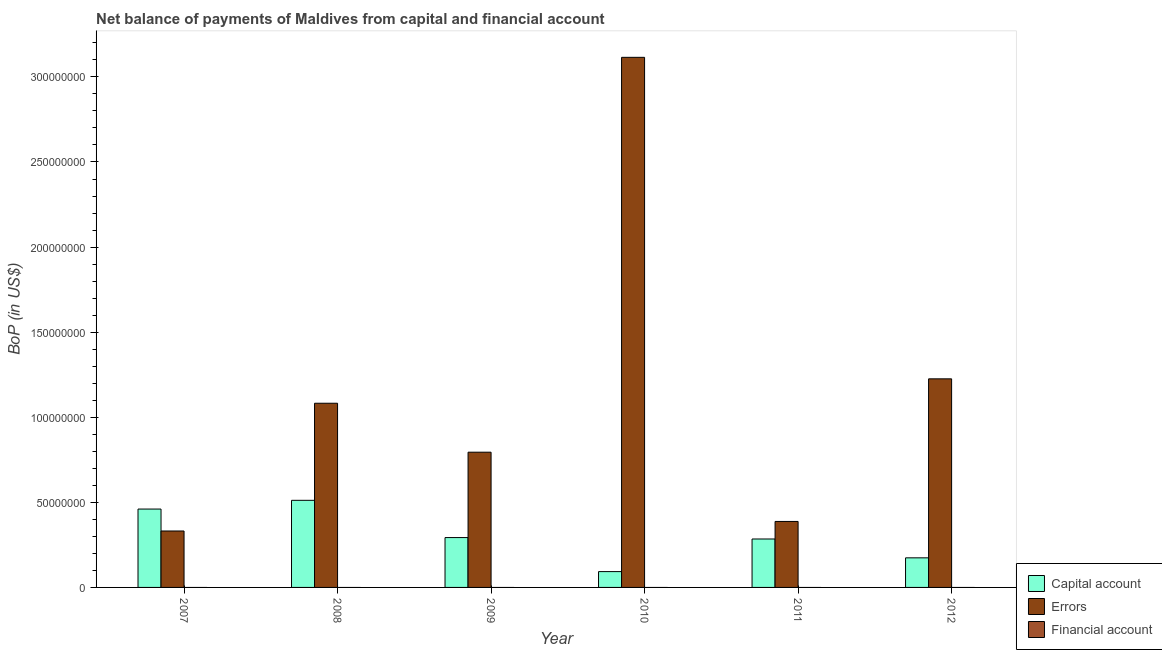How many different coloured bars are there?
Provide a short and direct response. 2. Are the number of bars on each tick of the X-axis equal?
Your answer should be very brief. Yes. What is the amount of errors in 2007?
Provide a short and direct response. 3.32e+07. Across all years, what is the maximum amount of net capital account?
Your response must be concise. 5.12e+07. Across all years, what is the minimum amount of errors?
Provide a succinct answer. 3.32e+07. What is the total amount of errors in the graph?
Offer a very short reply. 6.94e+08. What is the difference between the amount of net capital account in 2008 and that in 2009?
Keep it short and to the point. 2.19e+07. What is the difference between the amount of errors in 2007 and the amount of net capital account in 2011?
Your response must be concise. -5.61e+06. In how many years, is the amount of financial account greater than 80000000 US$?
Ensure brevity in your answer.  0. What is the ratio of the amount of net capital account in 2010 to that in 2012?
Provide a short and direct response. 0.53. What is the difference between the highest and the second highest amount of errors?
Offer a terse response. 1.89e+08. What is the difference between the highest and the lowest amount of errors?
Give a very brief answer. 2.78e+08. In how many years, is the amount of errors greater than the average amount of errors taken over all years?
Offer a terse response. 2. Is the sum of the amount of net capital account in 2008 and 2010 greater than the maximum amount of errors across all years?
Ensure brevity in your answer.  Yes. Is it the case that in every year, the sum of the amount of net capital account and amount of errors is greater than the amount of financial account?
Provide a succinct answer. Yes. How many bars are there?
Provide a succinct answer. 12. What is the difference between two consecutive major ticks on the Y-axis?
Make the answer very short. 5.00e+07. Where does the legend appear in the graph?
Provide a short and direct response. Bottom right. How many legend labels are there?
Ensure brevity in your answer.  3. How are the legend labels stacked?
Your response must be concise. Vertical. What is the title of the graph?
Your answer should be compact. Net balance of payments of Maldives from capital and financial account. Does "Injury" appear as one of the legend labels in the graph?
Your answer should be very brief. No. What is the label or title of the X-axis?
Your answer should be compact. Year. What is the label or title of the Y-axis?
Provide a succinct answer. BoP (in US$). What is the BoP (in US$) of Capital account in 2007?
Your response must be concise. 4.61e+07. What is the BoP (in US$) in Errors in 2007?
Your response must be concise. 3.32e+07. What is the BoP (in US$) in Capital account in 2008?
Keep it short and to the point. 5.12e+07. What is the BoP (in US$) of Errors in 2008?
Your answer should be compact. 1.08e+08. What is the BoP (in US$) in Financial account in 2008?
Your answer should be compact. 0. What is the BoP (in US$) of Capital account in 2009?
Your answer should be compact. 2.93e+07. What is the BoP (in US$) of Errors in 2009?
Provide a short and direct response. 7.95e+07. What is the BoP (in US$) of Financial account in 2009?
Keep it short and to the point. 0. What is the BoP (in US$) in Capital account in 2010?
Offer a terse response. 9.30e+06. What is the BoP (in US$) of Errors in 2010?
Provide a succinct answer. 3.11e+08. What is the BoP (in US$) in Financial account in 2010?
Offer a terse response. 0. What is the BoP (in US$) of Capital account in 2011?
Provide a short and direct response. 2.85e+07. What is the BoP (in US$) in Errors in 2011?
Keep it short and to the point. 3.88e+07. What is the BoP (in US$) of Financial account in 2011?
Offer a terse response. 0. What is the BoP (in US$) in Capital account in 2012?
Your response must be concise. 1.74e+07. What is the BoP (in US$) of Errors in 2012?
Give a very brief answer. 1.23e+08. What is the BoP (in US$) in Financial account in 2012?
Offer a terse response. 0. Across all years, what is the maximum BoP (in US$) in Capital account?
Give a very brief answer. 5.12e+07. Across all years, what is the maximum BoP (in US$) of Errors?
Give a very brief answer. 3.11e+08. Across all years, what is the minimum BoP (in US$) of Capital account?
Keep it short and to the point. 9.30e+06. Across all years, what is the minimum BoP (in US$) of Errors?
Offer a very short reply. 3.32e+07. What is the total BoP (in US$) of Capital account in the graph?
Offer a very short reply. 1.82e+08. What is the total BoP (in US$) of Errors in the graph?
Keep it short and to the point. 6.94e+08. What is the difference between the BoP (in US$) of Capital account in 2007 and that in 2008?
Give a very brief answer. -5.13e+06. What is the difference between the BoP (in US$) in Errors in 2007 and that in 2008?
Your answer should be very brief. -7.51e+07. What is the difference between the BoP (in US$) in Capital account in 2007 and that in 2009?
Offer a very short reply. 1.68e+07. What is the difference between the BoP (in US$) in Errors in 2007 and that in 2009?
Ensure brevity in your answer.  -4.63e+07. What is the difference between the BoP (in US$) in Capital account in 2007 and that in 2010?
Your response must be concise. 3.68e+07. What is the difference between the BoP (in US$) in Errors in 2007 and that in 2010?
Give a very brief answer. -2.78e+08. What is the difference between the BoP (in US$) in Capital account in 2007 and that in 2011?
Your answer should be very brief. 1.76e+07. What is the difference between the BoP (in US$) in Errors in 2007 and that in 2011?
Your response must be concise. -5.61e+06. What is the difference between the BoP (in US$) in Capital account in 2007 and that in 2012?
Keep it short and to the point. 2.87e+07. What is the difference between the BoP (in US$) of Errors in 2007 and that in 2012?
Provide a short and direct response. -8.94e+07. What is the difference between the BoP (in US$) in Capital account in 2008 and that in 2009?
Your response must be concise. 2.19e+07. What is the difference between the BoP (in US$) in Errors in 2008 and that in 2009?
Provide a short and direct response. 2.88e+07. What is the difference between the BoP (in US$) of Capital account in 2008 and that in 2010?
Offer a terse response. 4.19e+07. What is the difference between the BoP (in US$) of Errors in 2008 and that in 2010?
Keep it short and to the point. -2.03e+08. What is the difference between the BoP (in US$) of Capital account in 2008 and that in 2011?
Provide a short and direct response. 2.27e+07. What is the difference between the BoP (in US$) in Errors in 2008 and that in 2011?
Your answer should be very brief. 6.95e+07. What is the difference between the BoP (in US$) of Capital account in 2008 and that in 2012?
Your answer should be compact. 3.38e+07. What is the difference between the BoP (in US$) in Errors in 2008 and that in 2012?
Provide a succinct answer. -1.43e+07. What is the difference between the BoP (in US$) in Capital account in 2009 and that in 2010?
Offer a terse response. 2.00e+07. What is the difference between the BoP (in US$) of Errors in 2009 and that in 2010?
Your response must be concise. -2.32e+08. What is the difference between the BoP (in US$) of Capital account in 2009 and that in 2011?
Offer a terse response. 8.41e+05. What is the difference between the BoP (in US$) of Errors in 2009 and that in 2011?
Your answer should be very brief. 4.07e+07. What is the difference between the BoP (in US$) of Capital account in 2009 and that in 2012?
Offer a very short reply. 1.19e+07. What is the difference between the BoP (in US$) in Errors in 2009 and that in 2012?
Your response must be concise. -4.31e+07. What is the difference between the BoP (in US$) of Capital account in 2010 and that in 2011?
Offer a terse response. -1.92e+07. What is the difference between the BoP (in US$) of Errors in 2010 and that in 2011?
Keep it short and to the point. 2.73e+08. What is the difference between the BoP (in US$) of Capital account in 2010 and that in 2012?
Make the answer very short. -8.09e+06. What is the difference between the BoP (in US$) in Errors in 2010 and that in 2012?
Your answer should be compact. 1.89e+08. What is the difference between the BoP (in US$) in Capital account in 2011 and that in 2012?
Make the answer very short. 1.11e+07. What is the difference between the BoP (in US$) of Errors in 2011 and that in 2012?
Your answer should be very brief. -8.38e+07. What is the difference between the BoP (in US$) in Capital account in 2007 and the BoP (in US$) in Errors in 2008?
Make the answer very short. -6.22e+07. What is the difference between the BoP (in US$) in Capital account in 2007 and the BoP (in US$) in Errors in 2009?
Give a very brief answer. -3.34e+07. What is the difference between the BoP (in US$) in Capital account in 2007 and the BoP (in US$) in Errors in 2010?
Your response must be concise. -2.65e+08. What is the difference between the BoP (in US$) of Capital account in 2007 and the BoP (in US$) of Errors in 2011?
Your answer should be compact. 7.28e+06. What is the difference between the BoP (in US$) in Capital account in 2007 and the BoP (in US$) in Errors in 2012?
Ensure brevity in your answer.  -7.65e+07. What is the difference between the BoP (in US$) of Capital account in 2008 and the BoP (in US$) of Errors in 2009?
Your response must be concise. -2.83e+07. What is the difference between the BoP (in US$) in Capital account in 2008 and the BoP (in US$) in Errors in 2010?
Make the answer very short. -2.60e+08. What is the difference between the BoP (in US$) of Capital account in 2008 and the BoP (in US$) of Errors in 2011?
Ensure brevity in your answer.  1.24e+07. What is the difference between the BoP (in US$) in Capital account in 2008 and the BoP (in US$) in Errors in 2012?
Ensure brevity in your answer.  -7.14e+07. What is the difference between the BoP (in US$) of Capital account in 2009 and the BoP (in US$) of Errors in 2010?
Make the answer very short. -2.82e+08. What is the difference between the BoP (in US$) of Capital account in 2009 and the BoP (in US$) of Errors in 2011?
Provide a short and direct response. -9.47e+06. What is the difference between the BoP (in US$) of Capital account in 2009 and the BoP (in US$) of Errors in 2012?
Your answer should be very brief. -9.33e+07. What is the difference between the BoP (in US$) of Capital account in 2010 and the BoP (in US$) of Errors in 2011?
Provide a short and direct response. -2.95e+07. What is the difference between the BoP (in US$) of Capital account in 2010 and the BoP (in US$) of Errors in 2012?
Provide a succinct answer. -1.13e+08. What is the difference between the BoP (in US$) of Capital account in 2011 and the BoP (in US$) of Errors in 2012?
Your response must be concise. -9.41e+07. What is the average BoP (in US$) in Capital account per year?
Give a very brief answer. 3.03e+07. What is the average BoP (in US$) of Errors per year?
Your answer should be compact. 1.16e+08. In the year 2007, what is the difference between the BoP (in US$) of Capital account and BoP (in US$) of Errors?
Offer a very short reply. 1.29e+07. In the year 2008, what is the difference between the BoP (in US$) of Capital account and BoP (in US$) of Errors?
Your response must be concise. -5.71e+07. In the year 2009, what is the difference between the BoP (in US$) of Capital account and BoP (in US$) of Errors?
Keep it short and to the point. -5.02e+07. In the year 2010, what is the difference between the BoP (in US$) of Capital account and BoP (in US$) of Errors?
Your answer should be very brief. -3.02e+08. In the year 2011, what is the difference between the BoP (in US$) in Capital account and BoP (in US$) in Errors?
Ensure brevity in your answer.  -1.03e+07. In the year 2012, what is the difference between the BoP (in US$) of Capital account and BoP (in US$) of Errors?
Provide a short and direct response. -1.05e+08. What is the ratio of the BoP (in US$) of Capital account in 2007 to that in 2008?
Your answer should be compact. 0.9. What is the ratio of the BoP (in US$) in Errors in 2007 to that in 2008?
Your response must be concise. 0.31. What is the ratio of the BoP (in US$) in Capital account in 2007 to that in 2009?
Provide a short and direct response. 1.57. What is the ratio of the BoP (in US$) in Errors in 2007 to that in 2009?
Provide a short and direct response. 0.42. What is the ratio of the BoP (in US$) in Capital account in 2007 to that in 2010?
Provide a succinct answer. 4.95. What is the ratio of the BoP (in US$) in Errors in 2007 to that in 2010?
Keep it short and to the point. 0.11. What is the ratio of the BoP (in US$) in Capital account in 2007 to that in 2011?
Give a very brief answer. 1.62. What is the ratio of the BoP (in US$) in Errors in 2007 to that in 2011?
Keep it short and to the point. 0.86. What is the ratio of the BoP (in US$) of Capital account in 2007 to that in 2012?
Give a very brief answer. 2.65. What is the ratio of the BoP (in US$) of Errors in 2007 to that in 2012?
Offer a very short reply. 0.27. What is the ratio of the BoP (in US$) in Capital account in 2008 to that in 2009?
Ensure brevity in your answer.  1.75. What is the ratio of the BoP (in US$) in Errors in 2008 to that in 2009?
Ensure brevity in your answer.  1.36. What is the ratio of the BoP (in US$) of Capital account in 2008 to that in 2010?
Keep it short and to the point. 5.5. What is the ratio of the BoP (in US$) in Errors in 2008 to that in 2010?
Ensure brevity in your answer.  0.35. What is the ratio of the BoP (in US$) of Capital account in 2008 to that in 2011?
Your response must be concise. 1.8. What is the ratio of the BoP (in US$) of Errors in 2008 to that in 2011?
Offer a terse response. 2.79. What is the ratio of the BoP (in US$) of Capital account in 2008 to that in 2012?
Your response must be concise. 2.94. What is the ratio of the BoP (in US$) of Errors in 2008 to that in 2012?
Offer a terse response. 0.88. What is the ratio of the BoP (in US$) in Capital account in 2009 to that in 2010?
Provide a succinct answer. 3.15. What is the ratio of the BoP (in US$) of Errors in 2009 to that in 2010?
Make the answer very short. 0.26. What is the ratio of the BoP (in US$) in Capital account in 2009 to that in 2011?
Offer a terse response. 1.03. What is the ratio of the BoP (in US$) in Errors in 2009 to that in 2011?
Provide a succinct answer. 2.05. What is the ratio of the BoP (in US$) of Capital account in 2009 to that in 2012?
Provide a short and direct response. 1.68. What is the ratio of the BoP (in US$) in Errors in 2009 to that in 2012?
Your answer should be very brief. 0.65. What is the ratio of the BoP (in US$) of Capital account in 2010 to that in 2011?
Your response must be concise. 0.33. What is the ratio of the BoP (in US$) of Errors in 2010 to that in 2011?
Give a very brief answer. 8.03. What is the ratio of the BoP (in US$) in Capital account in 2010 to that in 2012?
Your answer should be compact. 0.53. What is the ratio of the BoP (in US$) in Errors in 2010 to that in 2012?
Your answer should be compact. 2.54. What is the ratio of the BoP (in US$) in Capital account in 2011 to that in 2012?
Give a very brief answer. 1.64. What is the ratio of the BoP (in US$) in Errors in 2011 to that in 2012?
Your answer should be compact. 0.32. What is the difference between the highest and the second highest BoP (in US$) of Capital account?
Provide a short and direct response. 5.13e+06. What is the difference between the highest and the second highest BoP (in US$) of Errors?
Provide a succinct answer. 1.89e+08. What is the difference between the highest and the lowest BoP (in US$) in Capital account?
Your answer should be compact. 4.19e+07. What is the difference between the highest and the lowest BoP (in US$) of Errors?
Give a very brief answer. 2.78e+08. 